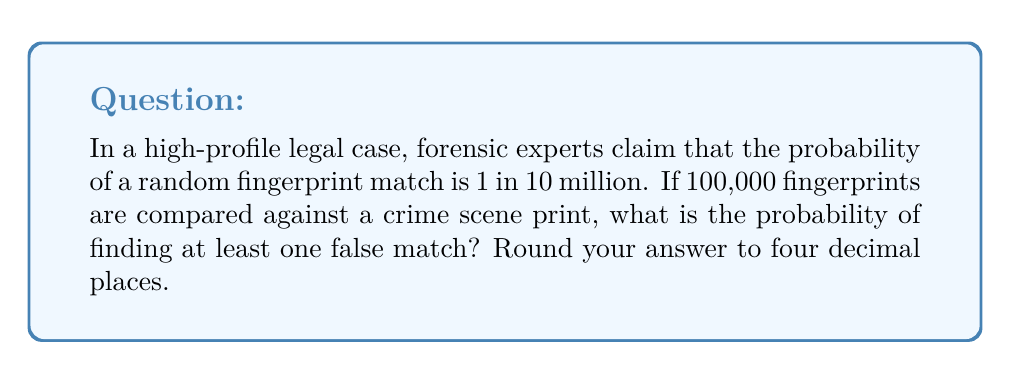Help me with this question. To solve this problem, we need to use probability theory and the concept of complement events. Let's break it down step-by-step:

1) First, let's define our events:
   A = at least one false match occurs
   A' = no false matches occur (complement of A)

2) We want to find P(A), but it's easier to calculate P(A') first.

3) The probability of a single fingerprint not matching is:
   $1 - \frac{1}{10,000,000} = 0.9999999$

4) For no false matches to occur, all 100,000 comparisons must not match. The probability of this is:
   $P(A') = (0.9999999)^{100,000}$

5) We can simplify this calculation using the approximation:
   $(1-x)^n \approx e^{-nx}$ when $x$ is small and $n$ is large.

   In our case, $x = \frac{1}{10,000,000}$ and $n = 100,000$

6) Applying this approximation:
   $P(A') \approx e^{-100,000 * \frac{1}{10,000,000}} = e^{-0.01} \approx 0.9900498$

7) Now, we can find P(A):
   $P(A) = 1 - P(A') \approx 1 - 0.9900498 = 0.0099502$

8) Rounding to four decimal places: 0.0100
Answer: 0.0100 